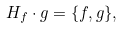Convert formula to latex. <formula><loc_0><loc_0><loc_500><loc_500>H _ { f } \cdot g = \{ f , g \} ,</formula> 